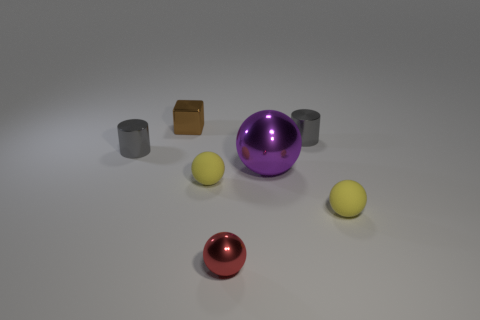What is the shape of the tiny gray object that is behind the metallic thing to the left of the tiny metallic block?
Give a very brief answer. Cylinder. Are there more shiny cubes behind the tiny red object than large blocks?
Ensure brevity in your answer.  Yes. What number of small gray things are behind the gray metal thing that is to the left of the tiny brown metal object?
Ensure brevity in your answer.  1. Is the small brown cube left of the small red shiny thing made of the same material as the large purple ball that is to the right of the small brown block?
Provide a succinct answer. Yes. What number of other metallic objects have the same shape as the big purple metal object?
Offer a very short reply. 1. Is the material of the small brown block the same as the small gray cylinder that is left of the purple shiny ball?
Provide a short and direct response. Yes. What is the material of the cube that is the same size as the red shiny sphere?
Make the answer very short. Metal. Are there any cyan metallic cylinders that have the same size as the purple metal thing?
Provide a short and direct response. No. The red metal thing that is the same size as the brown shiny cube is what shape?
Provide a short and direct response. Sphere. What number of other objects are the same color as the big object?
Offer a terse response. 0. 